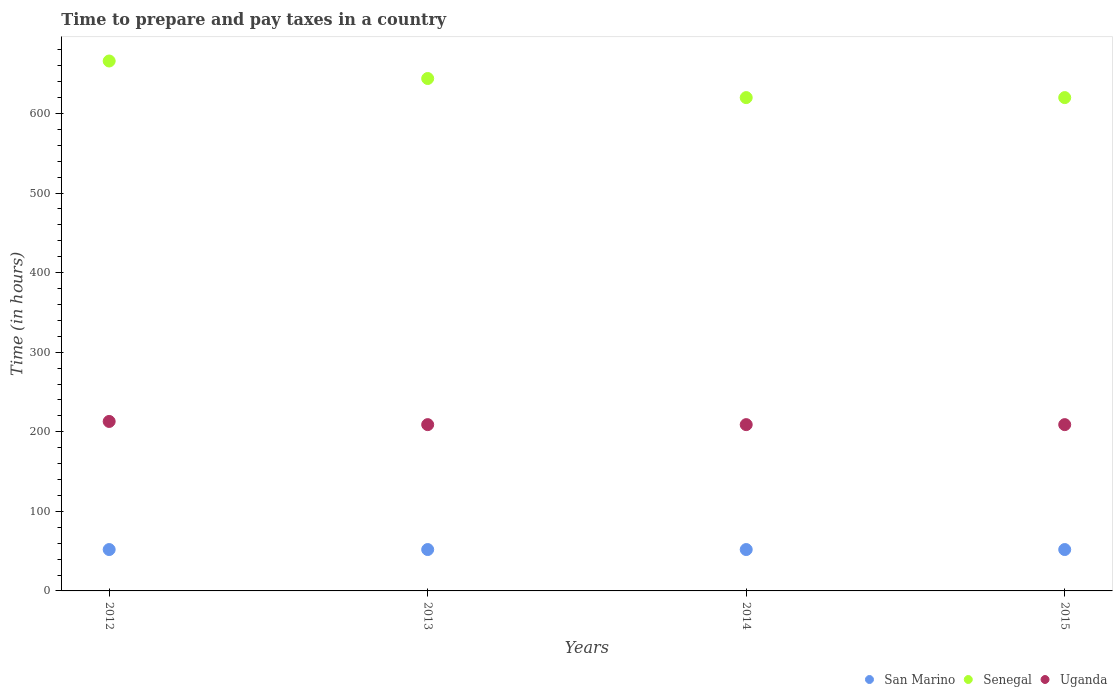Is the number of dotlines equal to the number of legend labels?
Provide a short and direct response. Yes. What is the number of hours required to prepare and pay taxes in Uganda in 2014?
Provide a succinct answer. 209. Across all years, what is the minimum number of hours required to prepare and pay taxes in Senegal?
Offer a very short reply. 620. In which year was the number of hours required to prepare and pay taxes in Uganda minimum?
Provide a succinct answer. 2013. What is the total number of hours required to prepare and pay taxes in Uganda in the graph?
Your response must be concise. 840. What is the difference between the number of hours required to prepare and pay taxes in San Marino in 2015 and the number of hours required to prepare and pay taxes in Uganda in 2012?
Offer a very short reply. -161. What is the average number of hours required to prepare and pay taxes in Senegal per year?
Give a very brief answer. 637.5. In the year 2012, what is the difference between the number of hours required to prepare and pay taxes in Senegal and number of hours required to prepare and pay taxes in Uganda?
Make the answer very short. 453. What is the ratio of the number of hours required to prepare and pay taxes in Senegal in 2013 to that in 2015?
Ensure brevity in your answer.  1.04. Is the number of hours required to prepare and pay taxes in Senegal in 2012 less than that in 2015?
Keep it short and to the point. No. What is the difference between the highest and the second highest number of hours required to prepare and pay taxes in San Marino?
Keep it short and to the point. 0. What is the difference between the highest and the lowest number of hours required to prepare and pay taxes in San Marino?
Your answer should be compact. 0. Is it the case that in every year, the sum of the number of hours required to prepare and pay taxes in Uganda and number of hours required to prepare and pay taxes in San Marino  is greater than the number of hours required to prepare and pay taxes in Senegal?
Make the answer very short. No. Is the number of hours required to prepare and pay taxes in Uganda strictly less than the number of hours required to prepare and pay taxes in San Marino over the years?
Give a very brief answer. No. Are the values on the major ticks of Y-axis written in scientific E-notation?
Provide a succinct answer. No. Does the graph contain any zero values?
Your answer should be very brief. No. Where does the legend appear in the graph?
Offer a very short reply. Bottom right. How many legend labels are there?
Give a very brief answer. 3. What is the title of the graph?
Make the answer very short. Time to prepare and pay taxes in a country. Does "Isle of Man" appear as one of the legend labels in the graph?
Provide a succinct answer. No. What is the label or title of the X-axis?
Offer a very short reply. Years. What is the label or title of the Y-axis?
Ensure brevity in your answer.  Time (in hours). What is the Time (in hours) of Senegal in 2012?
Offer a terse response. 666. What is the Time (in hours) in Uganda in 2012?
Your answer should be compact. 213. What is the Time (in hours) in San Marino in 2013?
Provide a short and direct response. 52. What is the Time (in hours) of Senegal in 2013?
Keep it short and to the point. 644. What is the Time (in hours) in Uganda in 2013?
Give a very brief answer. 209. What is the Time (in hours) of Senegal in 2014?
Provide a succinct answer. 620. What is the Time (in hours) of Uganda in 2014?
Ensure brevity in your answer.  209. What is the Time (in hours) of San Marino in 2015?
Provide a short and direct response. 52. What is the Time (in hours) in Senegal in 2015?
Provide a succinct answer. 620. What is the Time (in hours) of Uganda in 2015?
Offer a terse response. 209. Across all years, what is the maximum Time (in hours) in San Marino?
Provide a short and direct response. 52. Across all years, what is the maximum Time (in hours) in Senegal?
Provide a short and direct response. 666. Across all years, what is the maximum Time (in hours) of Uganda?
Keep it short and to the point. 213. Across all years, what is the minimum Time (in hours) of Senegal?
Ensure brevity in your answer.  620. Across all years, what is the minimum Time (in hours) in Uganda?
Offer a very short reply. 209. What is the total Time (in hours) in San Marino in the graph?
Make the answer very short. 208. What is the total Time (in hours) in Senegal in the graph?
Provide a short and direct response. 2550. What is the total Time (in hours) of Uganda in the graph?
Offer a terse response. 840. What is the difference between the Time (in hours) of San Marino in 2012 and that in 2013?
Your response must be concise. 0. What is the difference between the Time (in hours) in San Marino in 2012 and that in 2014?
Offer a terse response. 0. What is the difference between the Time (in hours) in Senegal in 2012 and that in 2014?
Give a very brief answer. 46. What is the difference between the Time (in hours) in Uganda in 2012 and that in 2014?
Offer a very short reply. 4. What is the difference between the Time (in hours) in San Marino in 2012 and that in 2015?
Provide a short and direct response. 0. What is the difference between the Time (in hours) of Uganda in 2012 and that in 2015?
Your answer should be compact. 4. What is the difference between the Time (in hours) of San Marino in 2013 and that in 2014?
Provide a short and direct response. 0. What is the difference between the Time (in hours) in Senegal in 2013 and that in 2014?
Keep it short and to the point. 24. What is the difference between the Time (in hours) in Uganda in 2013 and that in 2014?
Provide a short and direct response. 0. What is the difference between the Time (in hours) in San Marino in 2013 and that in 2015?
Your answer should be compact. 0. What is the difference between the Time (in hours) in Senegal in 2013 and that in 2015?
Your answer should be very brief. 24. What is the difference between the Time (in hours) in Uganda in 2013 and that in 2015?
Provide a short and direct response. 0. What is the difference between the Time (in hours) in San Marino in 2014 and that in 2015?
Offer a terse response. 0. What is the difference between the Time (in hours) of Senegal in 2014 and that in 2015?
Keep it short and to the point. 0. What is the difference between the Time (in hours) in San Marino in 2012 and the Time (in hours) in Senegal in 2013?
Ensure brevity in your answer.  -592. What is the difference between the Time (in hours) in San Marino in 2012 and the Time (in hours) in Uganda in 2013?
Provide a short and direct response. -157. What is the difference between the Time (in hours) in Senegal in 2012 and the Time (in hours) in Uganda in 2013?
Your answer should be compact. 457. What is the difference between the Time (in hours) of San Marino in 2012 and the Time (in hours) of Senegal in 2014?
Offer a terse response. -568. What is the difference between the Time (in hours) of San Marino in 2012 and the Time (in hours) of Uganda in 2014?
Offer a terse response. -157. What is the difference between the Time (in hours) of Senegal in 2012 and the Time (in hours) of Uganda in 2014?
Offer a very short reply. 457. What is the difference between the Time (in hours) of San Marino in 2012 and the Time (in hours) of Senegal in 2015?
Keep it short and to the point. -568. What is the difference between the Time (in hours) in San Marino in 2012 and the Time (in hours) in Uganda in 2015?
Give a very brief answer. -157. What is the difference between the Time (in hours) in Senegal in 2012 and the Time (in hours) in Uganda in 2015?
Your answer should be very brief. 457. What is the difference between the Time (in hours) of San Marino in 2013 and the Time (in hours) of Senegal in 2014?
Offer a very short reply. -568. What is the difference between the Time (in hours) in San Marino in 2013 and the Time (in hours) in Uganda in 2014?
Keep it short and to the point. -157. What is the difference between the Time (in hours) in Senegal in 2013 and the Time (in hours) in Uganda in 2014?
Provide a succinct answer. 435. What is the difference between the Time (in hours) in San Marino in 2013 and the Time (in hours) in Senegal in 2015?
Your answer should be very brief. -568. What is the difference between the Time (in hours) of San Marino in 2013 and the Time (in hours) of Uganda in 2015?
Your answer should be compact. -157. What is the difference between the Time (in hours) of Senegal in 2013 and the Time (in hours) of Uganda in 2015?
Your answer should be very brief. 435. What is the difference between the Time (in hours) in San Marino in 2014 and the Time (in hours) in Senegal in 2015?
Keep it short and to the point. -568. What is the difference between the Time (in hours) of San Marino in 2014 and the Time (in hours) of Uganda in 2015?
Offer a very short reply. -157. What is the difference between the Time (in hours) of Senegal in 2014 and the Time (in hours) of Uganda in 2015?
Make the answer very short. 411. What is the average Time (in hours) in San Marino per year?
Provide a succinct answer. 52. What is the average Time (in hours) of Senegal per year?
Your answer should be very brief. 637.5. What is the average Time (in hours) in Uganda per year?
Provide a short and direct response. 210. In the year 2012, what is the difference between the Time (in hours) in San Marino and Time (in hours) in Senegal?
Make the answer very short. -614. In the year 2012, what is the difference between the Time (in hours) of San Marino and Time (in hours) of Uganda?
Offer a very short reply. -161. In the year 2012, what is the difference between the Time (in hours) of Senegal and Time (in hours) of Uganda?
Provide a short and direct response. 453. In the year 2013, what is the difference between the Time (in hours) of San Marino and Time (in hours) of Senegal?
Ensure brevity in your answer.  -592. In the year 2013, what is the difference between the Time (in hours) in San Marino and Time (in hours) in Uganda?
Make the answer very short. -157. In the year 2013, what is the difference between the Time (in hours) in Senegal and Time (in hours) in Uganda?
Ensure brevity in your answer.  435. In the year 2014, what is the difference between the Time (in hours) of San Marino and Time (in hours) of Senegal?
Provide a short and direct response. -568. In the year 2014, what is the difference between the Time (in hours) in San Marino and Time (in hours) in Uganda?
Your response must be concise. -157. In the year 2014, what is the difference between the Time (in hours) in Senegal and Time (in hours) in Uganda?
Make the answer very short. 411. In the year 2015, what is the difference between the Time (in hours) in San Marino and Time (in hours) in Senegal?
Ensure brevity in your answer.  -568. In the year 2015, what is the difference between the Time (in hours) in San Marino and Time (in hours) in Uganda?
Your answer should be compact. -157. In the year 2015, what is the difference between the Time (in hours) in Senegal and Time (in hours) in Uganda?
Keep it short and to the point. 411. What is the ratio of the Time (in hours) in Senegal in 2012 to that in 2013?
Keep it short and to the point. 1.03. What is the ratio of the Time (in hours) in Uganda in 2012 to that in 2013?
Your answer should be compact. 1.02. What is the ratio of the Time (in hours) of Senegal in 2012 to that in 2014?
Keep it short and to the point. 1.07. What is the ratio of the Time (in hours) of Uganda in 2012 to that in 2014?
Provide a succinct answer. 1.02. What is the ratio of the Time (in hours) in San Marino in 2012 to that in 2015?
Provide a short and direct response. 1. What is the ratio of the Time (in hours) of Senegal in 2012 to that in 2015?
Keep it short and to the point. 1.07. What is the ratio of the Time (in hours) of Uganda in 2012 to that in 2015?
Your answer should be very brief. 1.02. What is the ratio of the Time (in hours) in San Marino in 2013 to that in 2014?
Keep it short and to the point. 1. What is the ratio of the Time (in hours) in Senegal in 2013 to that in 2014?
Provide a succinct answer. 1.04. What is the ratio of the Time (in hours) in San Marino in 2013 to that in 2015?
Ensure brevity in your answer.  1. What is the ratio of the Time (in hours) in Senegal in 2013 to that in 2015?
Keep it short and to the point. 1.04. What is the ratio of the Time (in hours) of Uganda in 2014 to that in 2015?
Make the answer very short. 1. What is the difference between the highest and the second highest Time (in hours) in San Marino?
Your answer should be very brief. 0. What is the difference between the highest and the lowest Time (in hours) in San Marino?
Your answer should be very brief. 0. What is the difference between the highest and the lowest Time (in hours) in Uganda?
Offer a very short reply. 4. 